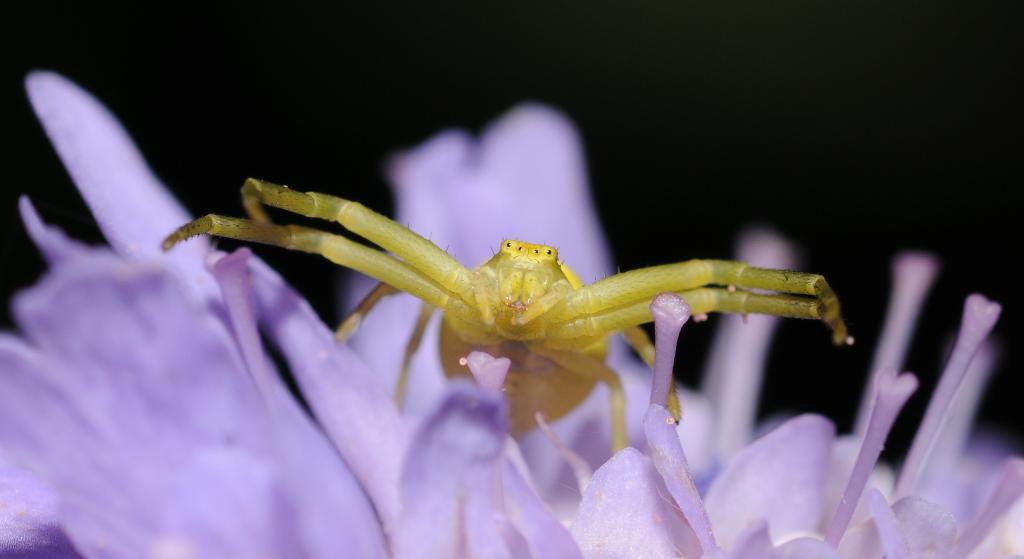Could you give a brief overview of what you see in this image? In this picture there is a green grasshopper sitting on the blue color flower. Behind there is a black background. 